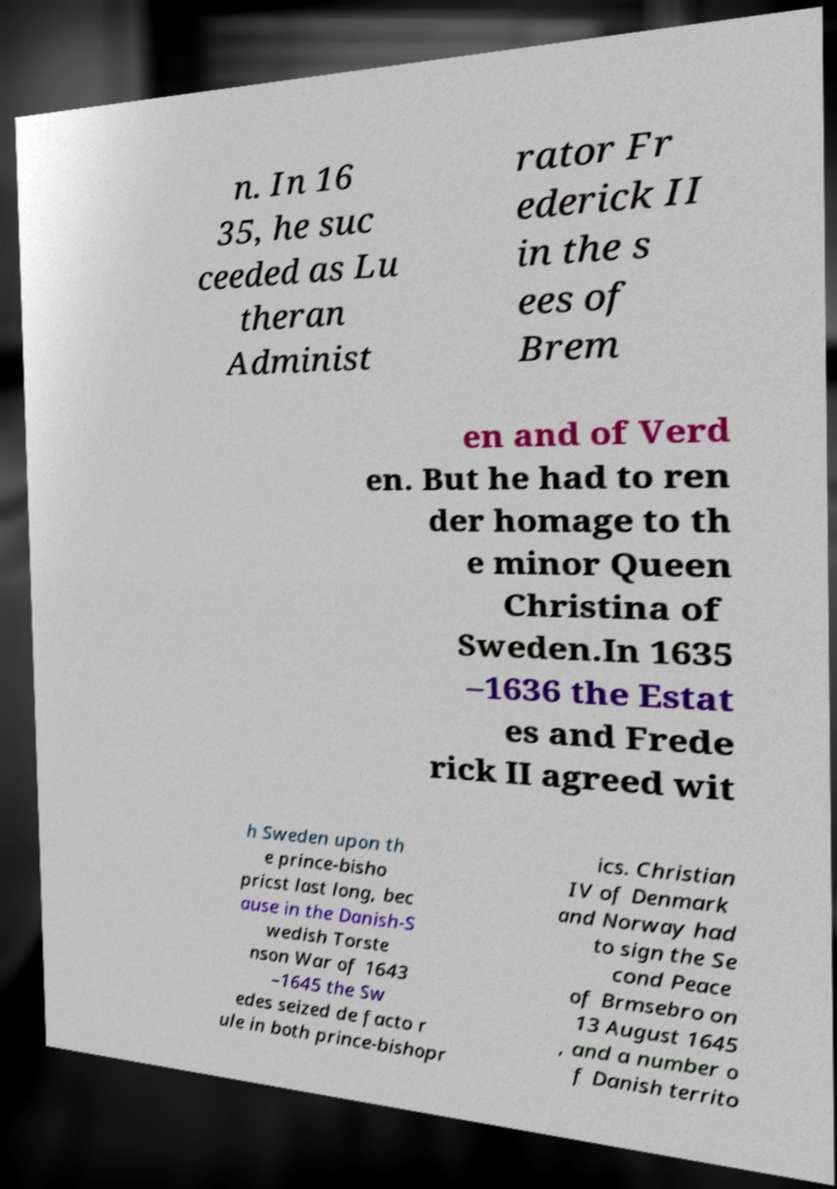What messages or text are displayed in this image? I need them in a readable, typed format. n. In 16 35, he suc ceeded as Lu theran Administ rator Fr ederick II in the s ees of Brem en and of Verd en. But he had to ren der homage to th e minor Queen Christina of Sweden.In 1635 –1636 the Estat es and Frede rick II agreed wit h Sweden upon th e prince-bisho pricst last long, bec ause in the Danish-S wedish Torste nson War of 1643 –1645 the Sw edes seized de facto r ule in both prince-bishopr ics. Christian IV of Denmark and Norway had to sign the Se cond Peace of Brmsebro on 13 August 1645 , and a number o f Danish territo 